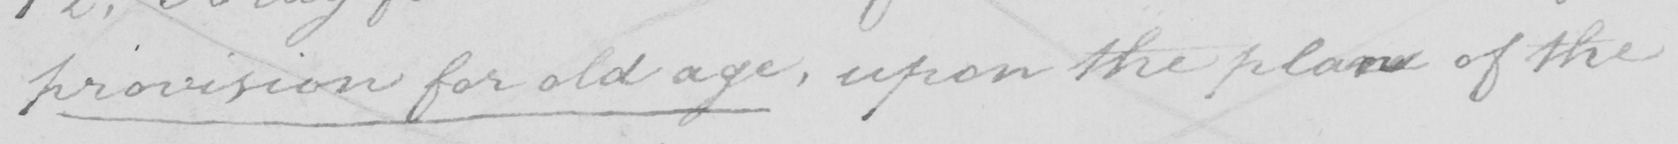What does this handwritten line say? provision for old age , upon the plan of the 